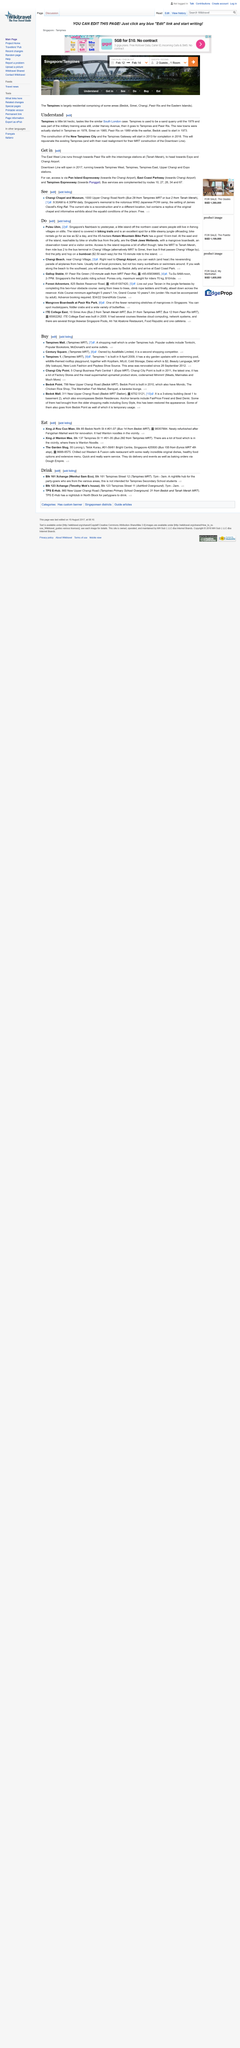Specify some key components in this picture. The Tampines encompasses the areas of Bedok, Simei, Changi, Pasi Ris, and the Eastern Islands, which are all part of the Tampines. During my walk on the beach, I discovered that Bedock Jetty and East Coast Park are located to the southeast of my current location. This reservation will accommodate two guests. Pulau Ubin is a small island located off the northern coast of Singapore, known for its natural beauty and cultural heritage. In Tampines, new construction started in 1978 and 2013. 